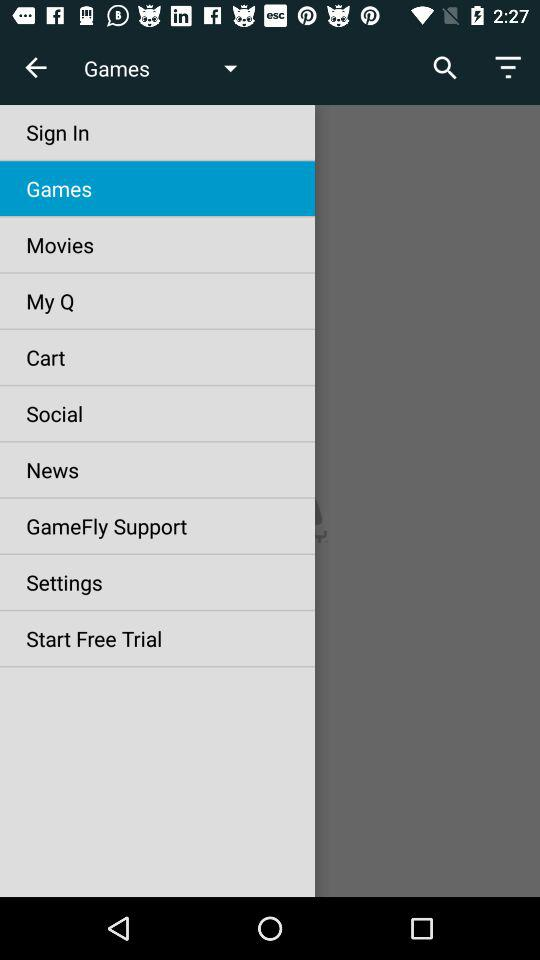Which item is selected? The selected item is "Games". 